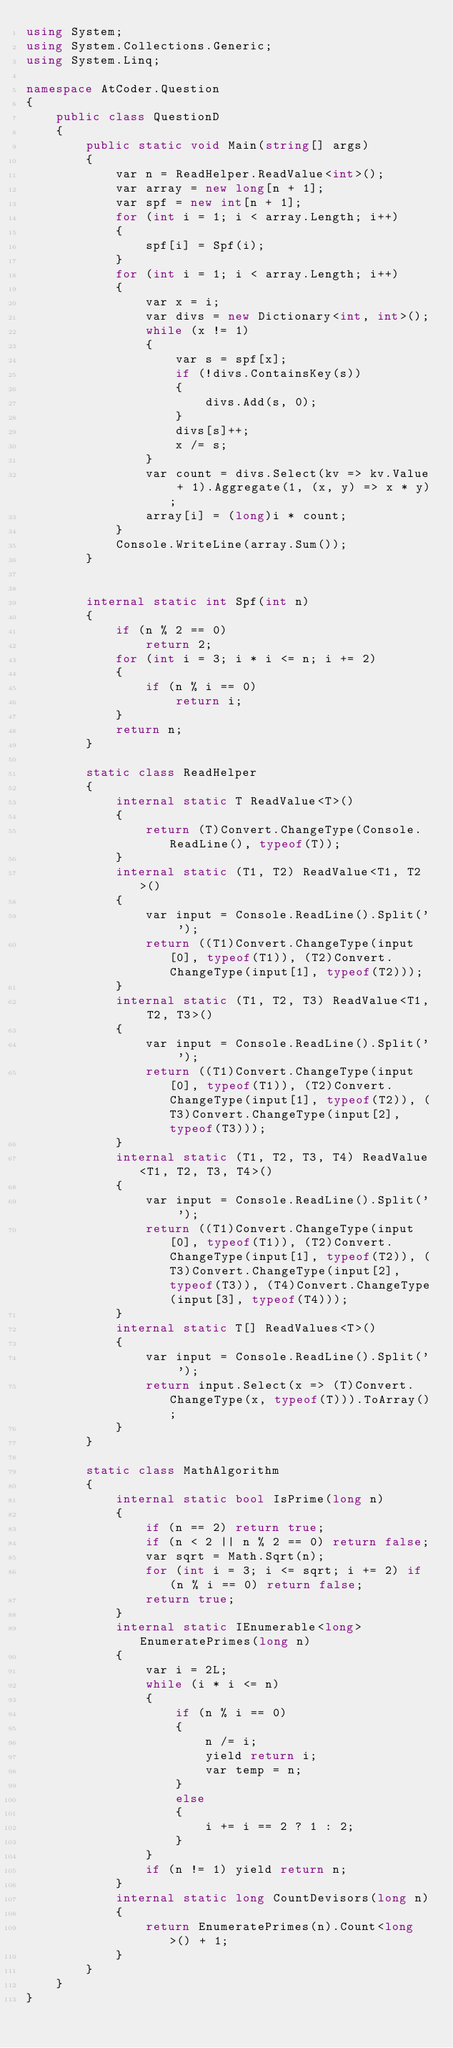Convert code to text. <code><loc_0><loc_0><loc_500><loc_500><_C#_>using System;
using System.Collections.Generic;
using System.Linq;

namespace AtCoder.Question
{
    public class QuestionD
    {
        public static void Main(string[] args)
        {
            var n = ReadHelper.ReadValue<int>();
            var array = new long[n + 1];
            var spf = new int[n + 1];
            for (int i = 1; i < array.Length; i++)
            {
                spf[i] = Spf(i);
            }
            for (int i = 1; i < array.Length; i++)
            {
                var x = i;
                var divs = new Dictionary<int, int>();
                while (x != 1)
                {
                    var s = spf[x];
                    if (!divs.ContainsKey(s))
                    {
                        divs.Add(s, 0);
                    }
                    divs[s]++;
                    x /= s;
                }
                var count = divs.Select(kv => kv.Value + 1).Aggregate(1, (x, y) => x * y);
                array[i] = (long)i * count;
            }
            Console.WriteLine(array.Sum());
        }


        internal static int Spf(int n)
        {
            if (n % 2 == 0)
                return 2;
            for (int i = 3; i * i <= n; i += 2)
            {
                if (n % i == 0)
                    return i;
            }
            return n;
        }

        static class ReadHelper
        {
            internal static T ReadValue<T>()
            {
                return (T)Convert.ChangeType(Console.ReadLine(), typeof(T));
            }
            internal static (T1, T2) ReadValue<T1, T2>()
            {
                var input = Console.ReadLine().Split(' ');
                return ((T1)Convert.ChangeType(input[0], typeof(T1)), (T2)Convert.ChangeType(input[1], typeof(T2)));
            }
            internal static (T1, T2, T3) ReadValue<T1, T2, T3>()
            {
                var input = Console.ReadLine().Split(' ');
                return ((T1)Convert.ChangeType(input[0], typeof(T1)), (T2)Convert.ChangeType(input[1], typeof(T2)), (T3)Convert.ChangeType(input[2], typeof(T3)));
            }
            internal static (T1, T2, T3, T4) ReadValue<T1, T2, T3, T4>()
            {
                var input = Console.ReadLine().Split(' ');
                return ((T1)Convert.ChangeType(input[0], typeof(T1)), (T2)Convert.ChangeType(input[1], typeof(T2)), (T3)Convert.ChangeType(input[2], typeof(T3)), (T4)Convert.ChangeType(input[3], typeof(T4)));
            }
            internal static T[] ReadValues<T>()
            {
                var input = Console.ReadLine().Split(' ');
                return input.Select(x => (T)Convert.ChangeType(x, typeof(T))).ToArray();
            }
        }

        static class MathAlgorithm
        {
            internal static bool IsPrime(long n)
            {
                if (n == 2) return true;
                if (n < 2 || n % 2 == 0) return false;
                var sqrt = Math.Sqrt(n);
                for (int i = 3; i <= sqrt; i += 2) if (n % i == 0) return false;
                return true;
            }
            internal static IEnumerable<long> EnumeratePrimes(long n)
            {
                var i = 2L;
                while (i * i <= n)
                {
                    if (n % i == 0)
                    {
                        n /= i;
                        yield return i;
                        var temp = n;
                    }
                    else
                    {
                        i += i == 2 ? 1 : 2;
                    }
                }
                if (n != 1) yield return n;
            }
            internal static long CountDevisors(long n)
            {
                return EnumeratePrimes(n).Count<long>() + 1;
            }
        }
    }
}
</code> 